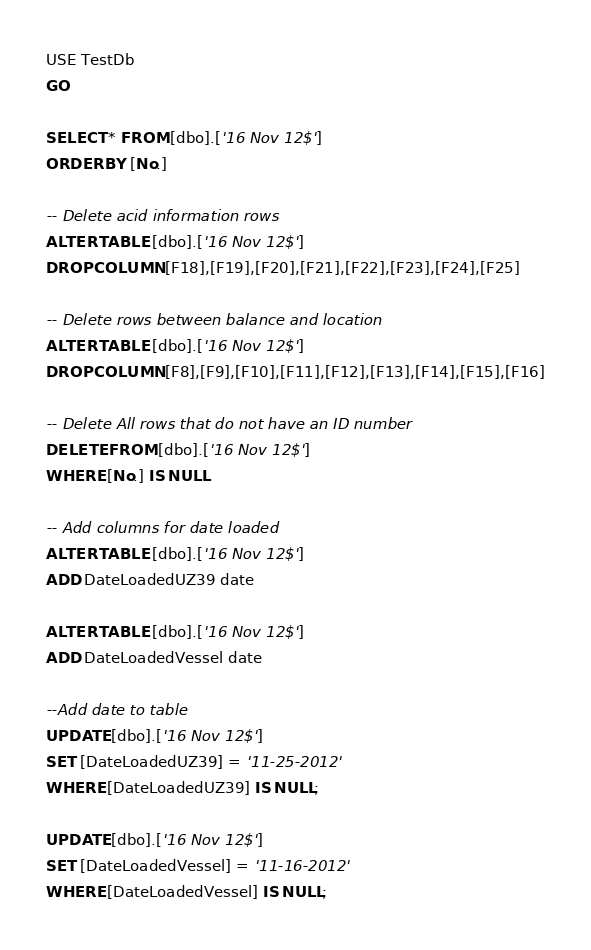<code> <loc_0><loc_0><loc_500><loc_500><_SQL_>USE TestDb
GO

SELECT * FROM [dbo].['16 Nov 12$']
ORDER BY [No.] 

-- Delete acid information rows
ALTER TABLE [dbo].['16 Nov 12$']
DROP COLUMN [F18],[F19],[F20],[F21],[F22],[F23],[F24],[F25]

-- Delete rows between balance and location
ALTER TABLE [dbo].['16 Nov 12$']
DROP COLUMN [F8],[F9],[F10],[F11],[F12],[F13],[F14],[F15],[F16]

-- Delete All rows that do not have an ID number
DELETE FROM [dbo].['16 Nov 12$']
WHERE [No.] IS NULL

-- Add columns for date loaded
ALTER TABLE [dbo].['16 Nov 12$']
ADD DateLoadedUZ39 date

ALTER TABLE [dbo].['16 Nov 12$']
ADD DateLoadedVessel date

--Add date to table 
UPDATE [dbo].['16 Nov 12$']
SET [DateLoadedUZ39] = '11-25-2012'
WHERE [DateLoadedUZ39] IS NULL;

UPDATE [dbo].['16 Nov 12$']
SET [DateLoadedVessel] = '11-16-2012'
WHERE [DateLoadedVessel] IS NULL;</code> 